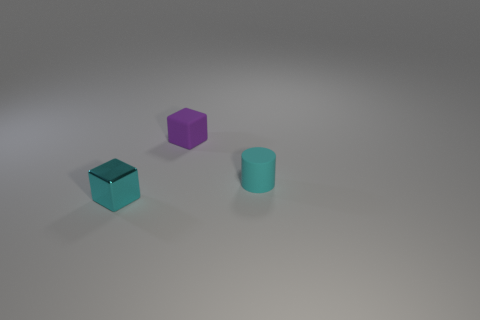Add 1 small purple matte cubes. How many objects exist? 4 Subtract all cubes. How many objects are left? 1 Add 2 metallic blocks. How many metallic blocks are left? 3 Add 1 tiny things. How many tiny things exist? 4 Subtract 0 brown balls. How many objects are left? 3 Subtract all small matte cubes. Subtract all small matte blocks. How many objects are left? 1 